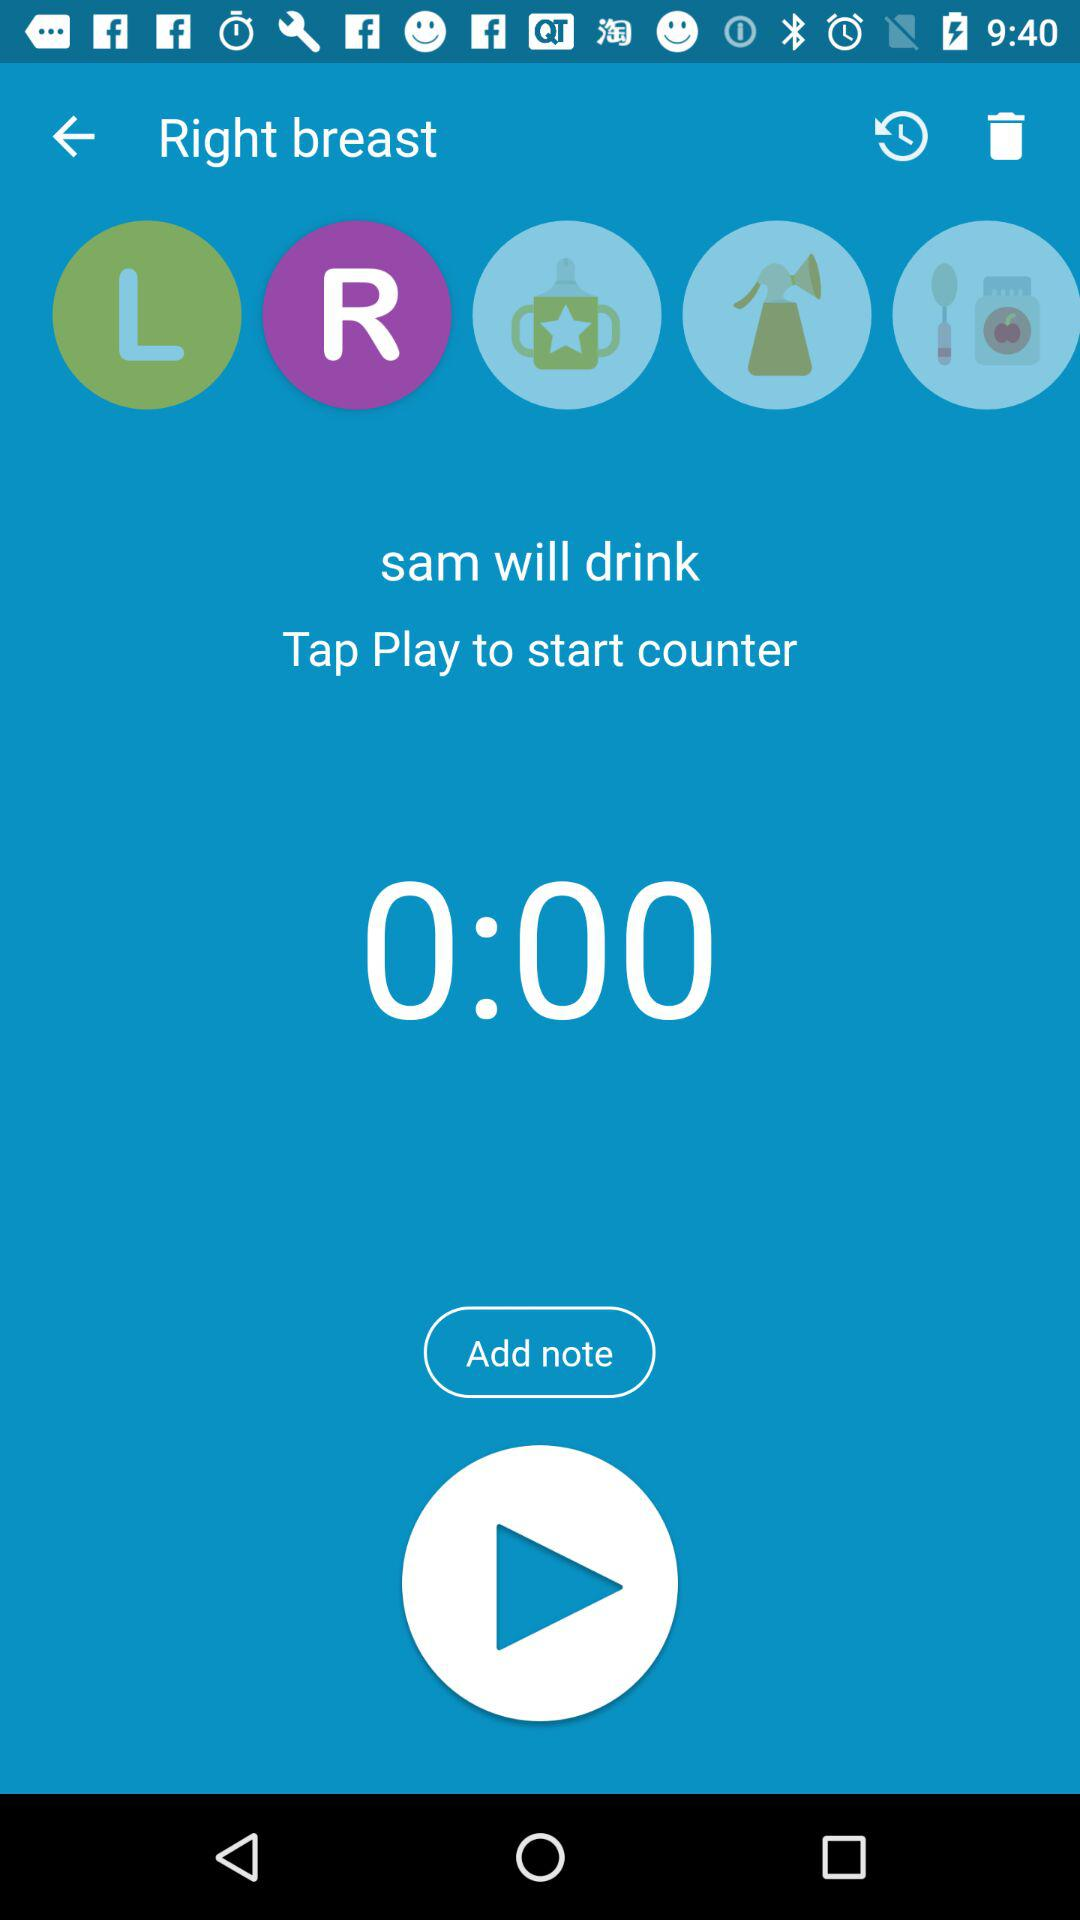Which option is selected? The selected option is "R". 